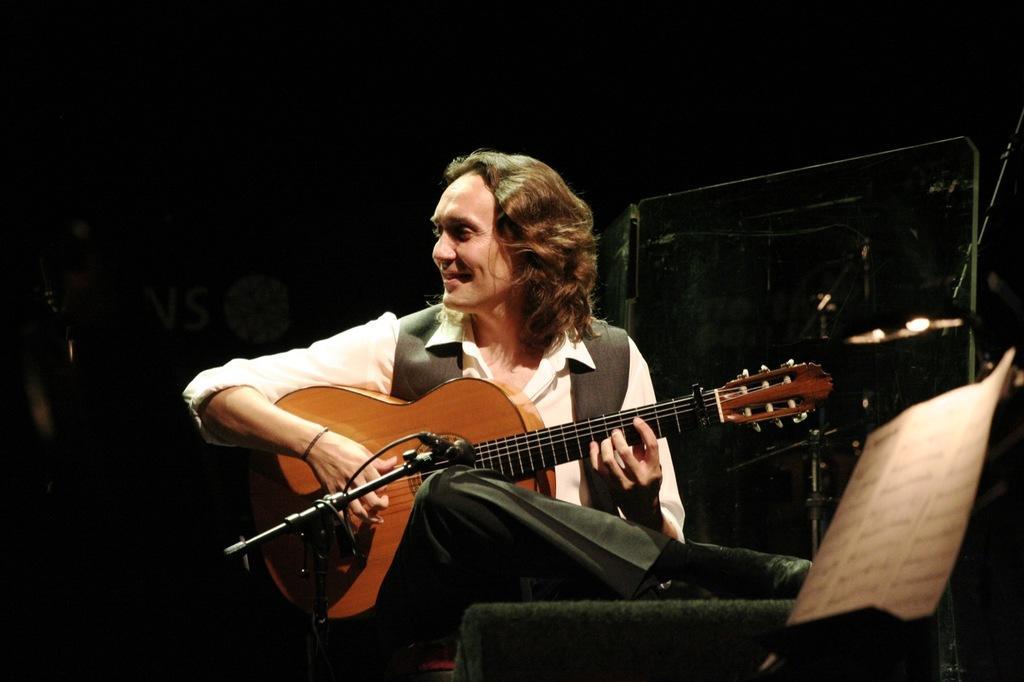Could you give a brief overview of what you see in this image? In this image, In the middle there is a man sitting and holding a music instrument which is in yellow color, There is a microphone which is in black color. 